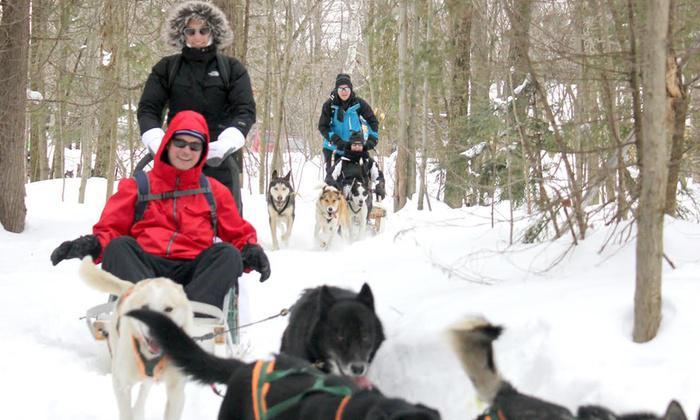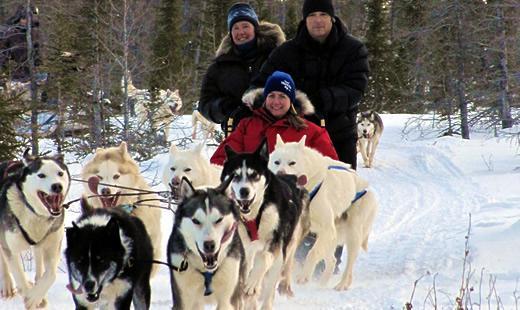The first image is the image on the left, the second image is the image on the right. Assess this claim about the two images: "The lead dog sled teams in the left and right images head forward but are angled slightly away from each other so they would not collide.". Correct or not? Answer yes or no. No. The first image is the image on the left, the second image is the image on the right. Evaluate the accuracy of this statement regarding the images: "There are two or more dog sled teams in the left image.". Is it true? Answer yes or no. Yes. 